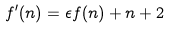Convert formula to latex. <formula><loc_0><loc_0><loc_500><loc_500>f ^ { \prime } ( n ) = \epsilon f ( n ) + n + 2</formula> 